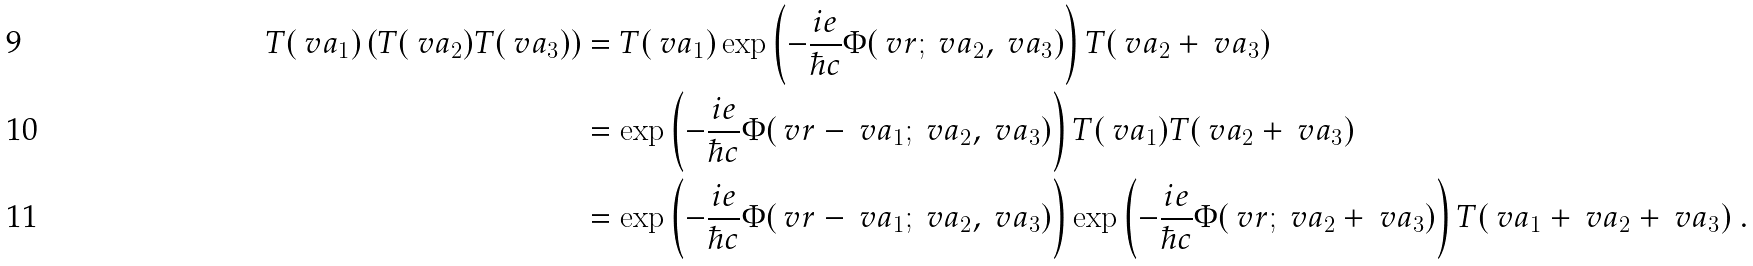<formula> <loc_0><loc_0><loc_500><loc_500>T ( \ v a _ { 1 } ) \left ( T ( \ v a _ { 2 } ) T ( \ v a _ { 3 } ) \right ) & = T ( \ v a _ { 1 } ) \exp \left ( - \frac { i e } { \hbar { c } } \Phi ( \ v r ; \ v a _ { 2 } , \ v a _ { 3 } ) \right ) T ( \ v a _ { 2 } + \ v a _ { 3 } ) \\ & = \exp \left ( - \frac { i e } { \hbar { c } } \Phi ( \ v r - \ v a _ { 1 } ; \ v a _ { 2 } , \ v a _ { 3 } ) \right ) T ( \ v a _ { 1 } ) T ( \ v a _ { 2 } + \ v a _ { 3 } ) \\ & = \exp \left ( - \frac { i e } { \hbar { c } } \Phi ( \ v r - \ v a _ { 1 } ; \ v a _ { 2 } , \ v a _ { 3 } ) \right ) \exp \left ( - \frac { i e } { \hbar { c } } \Phi ( \ v r ; \ v a _ { 2 } + \ v a _ { 3 } ) \right ) T ( \ v a _ { 1 } + \ v a _ { 2 } + \ v a _ { 3 } ) \ .</formula> 